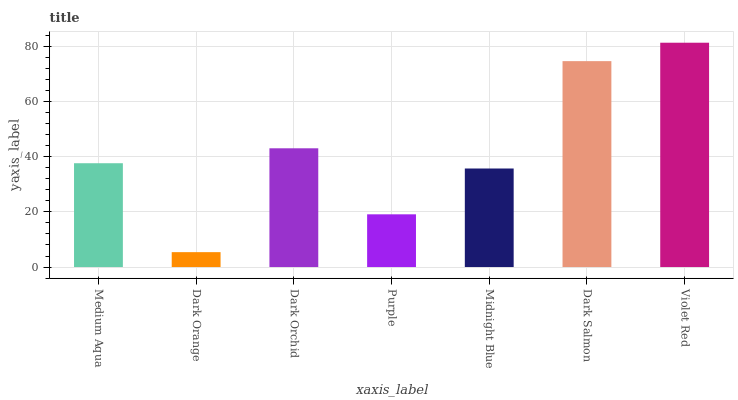Is Dark Orange the minimum?
Answer yes or no. Yes. Is Violet Red the maximum?
Answer yes or no. Yes. Is Dark Orchid the minimum?
Answer yes or no. No. Is Dark Orchid the maximum?
Answer yes or no. No. Is Dark Orchid greater than Dark Orange?
Answer yes or no. Yes. Is Dark Orange less than Dark Orchid?
Answer yes or no. Yes. Is Dark Orange greater than Dark Orchid?
Answer yes or no. No. Is Dark Orchid less than Dark Orange?
Answer yes or no. No. Is Medium Aqua the high median?
Answer yes or no. Yes. Is Medium Aqua the low median?
Answer yes or no. Yes. Is Dark Salmon the high median?
Answer yes or no. No. Is Midnight Blue the low median?
Answer yes or no. No. 